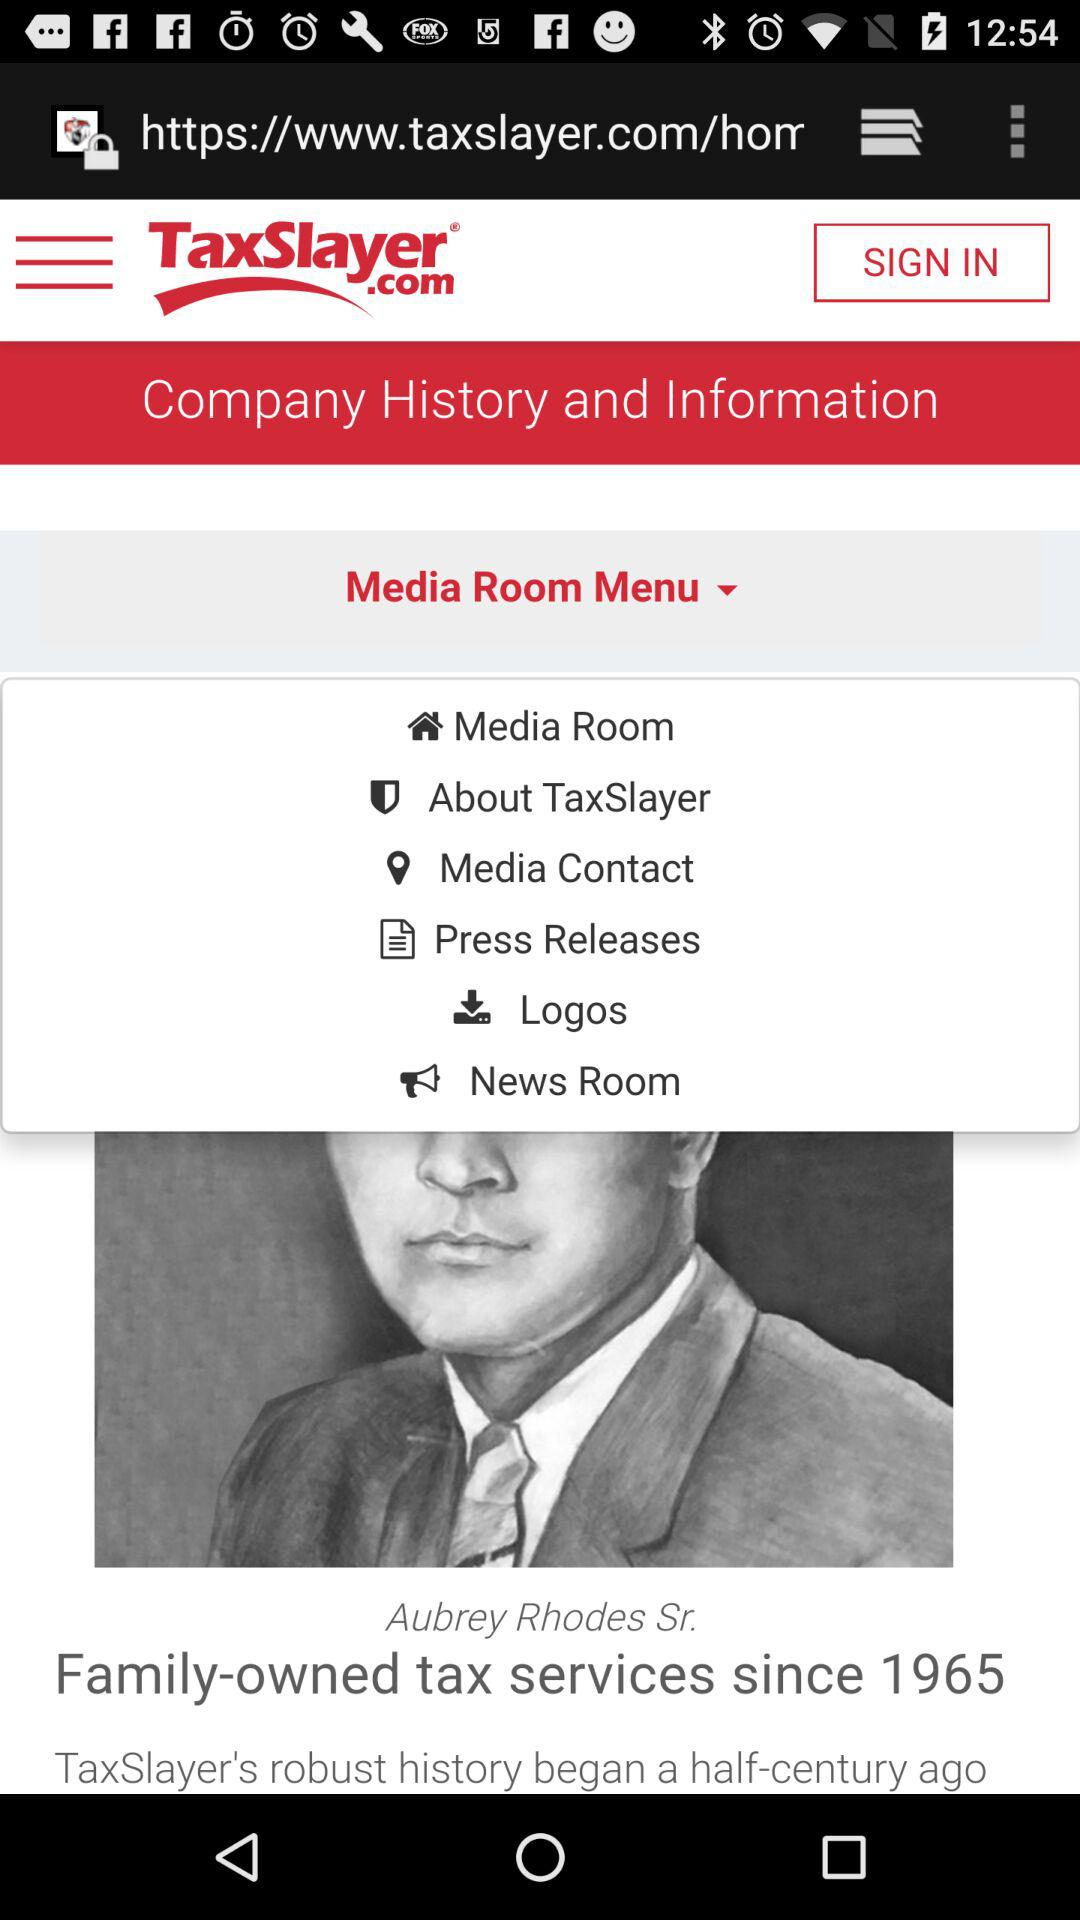What is the name of the application? The name of the application is "TaxSlayer". 